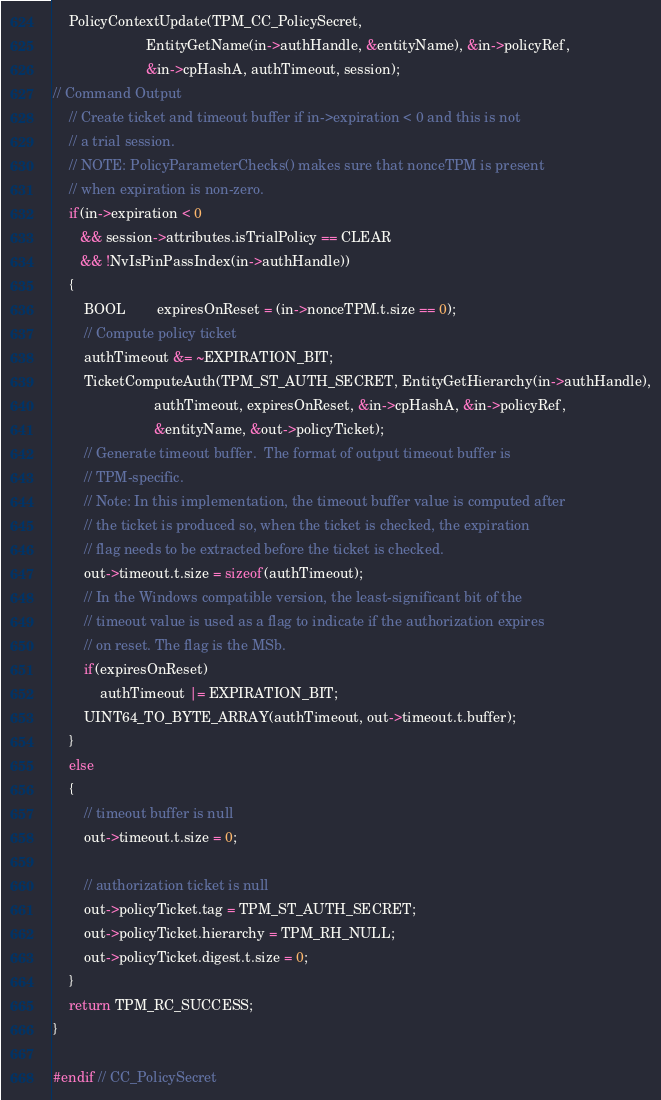Convert code to text. <code><loc_0><loc_0><loc_500><loc_500><_C_>    PolicyContextUpdate(TPM_CC_PolicySecret,
                        EntityGetName(in->authHandle, &entityName), &in->policyRef,
                        &in->cpHashA, authTimeout, session);
// Command Output
    // Create ticket and timeout buffer if in->expiration < 0 and this is not
    // a trial session.
    // NOTE: PolicyParameterChecks() makes sure that nonceTPM is present
    // when expiration is non-zero.
    if(in->expiration < 0
       && session->attributes.isTrialPolicy == CLEAR
       && !NvIsPinPassIndex(in->authHandle))
    {
        BOOL        expiresOnReset = (in->nonceTPM.t.size == 0);
        // Compute policy ticket
        authTimeout &= ~EXPIRATION_BIT;
        TicketComputeAuth(TPM_ST_AUTH_SECRET, EntityGetHierarchy(in->authHandle),
                          authTimeout, expiresOnReset, &in->cpHashA, &in->policyRef,
                          &entityName, &out->policyTicket);
        // Generate timeout buffer.  The format of output timeout buffer is
        // TPM-specific.
        // Note: In this implementation, the timeout buffer value is computed after
        // the ticket is produced so, when the ticket is checked, the expiration
        // flag needs to be extracted before the ticket is checked.
        out->timeout.t.size = sizeof(authTimeout);
        // In the Windows compatible version, the least-significant bit of the
        // timeout value is used as a flag to indicate if the authorization expires
        // on reset. The flag is the MSb.
        if(expiresOnReset)
            authTimeout |= EXPIRATION_BIT;
        UINT64_TO_BYTE_ARRAY(authTimeout, out->timeout.t.buffer);
    }
    else
    {
        // timeout buffer is null
        out->timeout.t.size = 0;

        // authorization ticket is null
        out->policyTicket.tag = TPM_ST_AUTH_SECRET;
        out->policyTicket.hierarchy = TPM_RH_NULL;
        out->policyTicket.digest.t.size = 0;
    }
    return TPM_RC_SUCCESS;
}

#endif // CC_PolicySecret</code> 